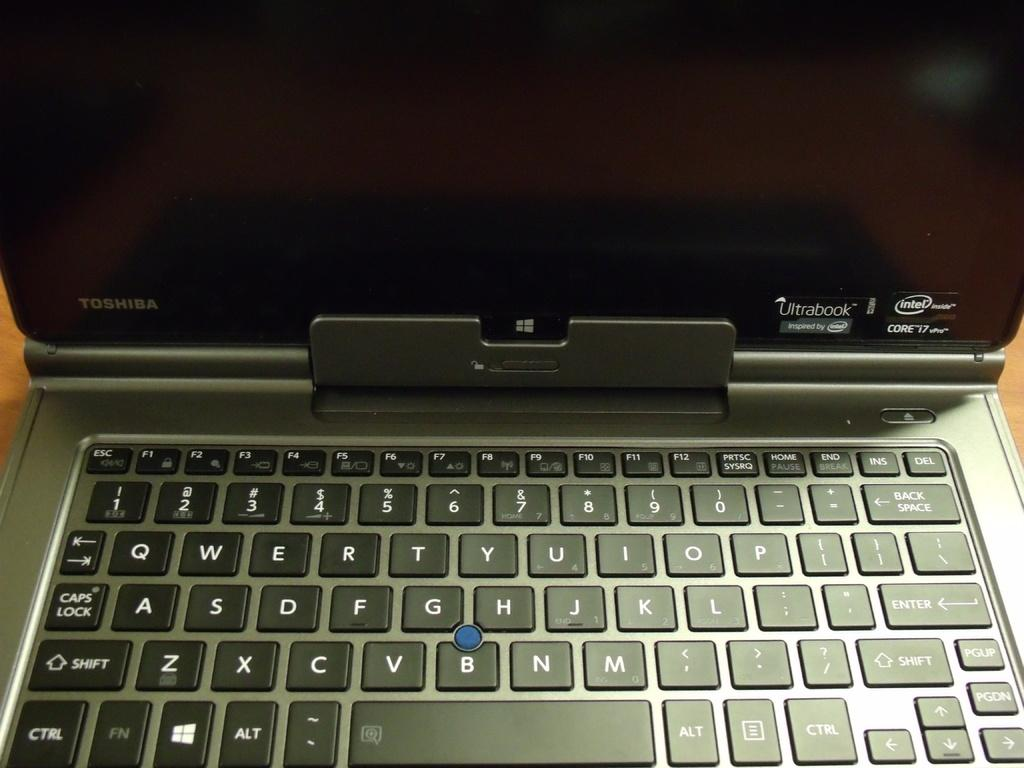<image>
Give a short and clear explanation of the subsequent image. A Toshiba Ultrabook laptop that runs Windows, has an Intel processor, and runs Core I7 vPro is being shown. 